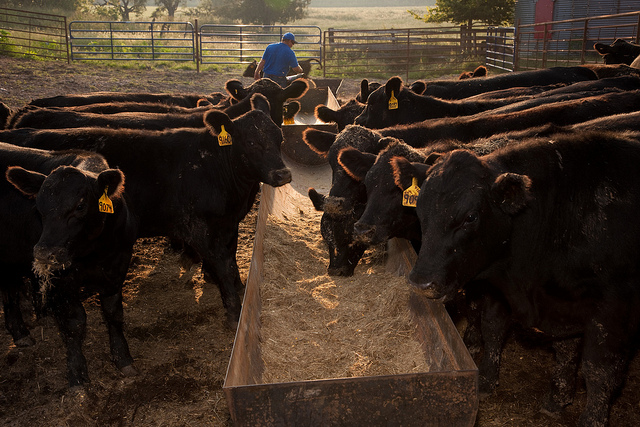<image>What are the noses on the animals called? The noses on the animals are typically called "snouts". However, without a specific image, the exact answer is unknown. What country is this? I don't know the exact country. But it seems like United States. What country is this? I am not sure what country this is. It can be United States, USA or America. What are the noses on the animals called? I don't know what the noses on the animals are called. It can be 'noses', 'cow noses', 'snout' or 'snouts'. 